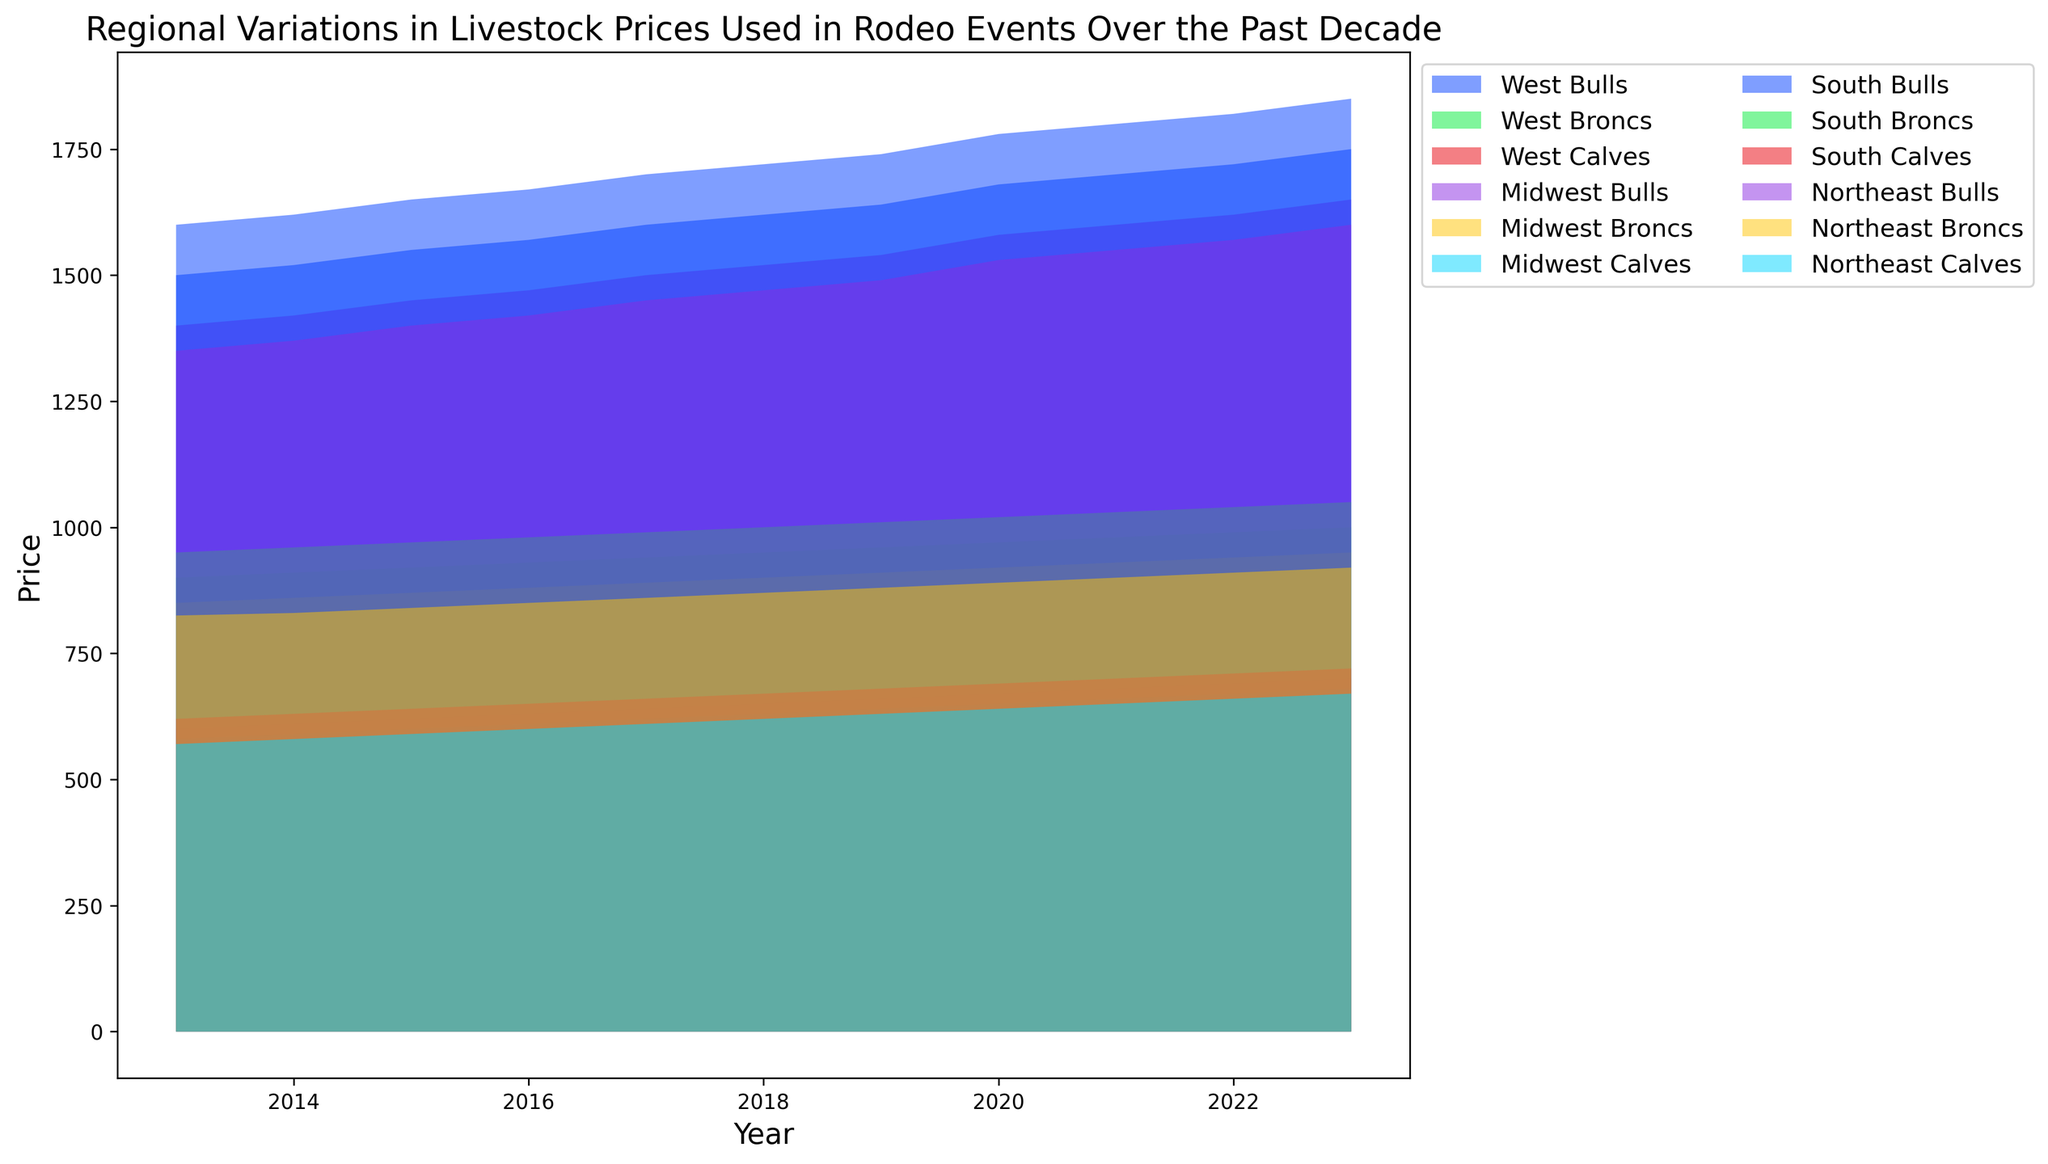Which region had the highest price for Bulls in 2023? By examining the topmost filled area in the chart for 2023, focus on the colors representing Bulls prices. The highest value is found by checking which region's Bulls price area reaches the highest point on the y-axis.
Answer: South How has the average price for Broncs in the Midwest changed from 2013 to 2023? Identify the Broncs prices for the Midwest in 2013 and 2023, then calculate the arithmetic mean for both years and compare them.
Answer: Increased Which region maintained the most consistent price for Calves over the decade? Look for the region where the Calves filled area shows the least variation (minimal ups and downs) over the years.
Answer: Midwest By how much has the price of Bulls in the West region increased from 2015 to 2020? Locate the Bull prices for the West region in 2015 and 2020. Subtract the price in 2015 from the price in 2020.
Answer: 130 Compare the trends of Broncs' prices in the South and Northeast regions; which region saw a more significant increase? Observe the slopes of the filled areas representing Broncs for the South and Northeast regions and compare their upward trends.
Answer: South What was the price range for Calves in the Northeast in 2021? Identify the filled area for Calves in the Northeast in 2021, locate the lowest and highest points of this filled area to determine the range.
Answer: 650-900 Identify the year when Bull prices in the South first crossed over $1800. Look at the filled area for Bulls in the South region and find the first year where the topmost point exceeds the $1800 line.
Answer: 2021 Did the price of Bulls in the Northeast ever surpass the price of Broncs in the Midwest during the past decade? Compare the filled areas for Bulls in the Northeast and Broncs in the Midwest by checking if the vertical boundary of Northeast Bulls exceeds that of Midwest Broncs at any point.
Answer: No What's the combined average price of Calves across all regions in 2019? Sum up the Calves prices for all regions in 2019 and divide by the number of regions to find the average.
Answer: 652.5 Between which consecutive years did the West see the steepest increase in Bulls' prices? Examine the filled area for Bulls in the West region and identify two consecutive years with the sharpest upward slope on the y-axis.
Answer: 2019-2020 